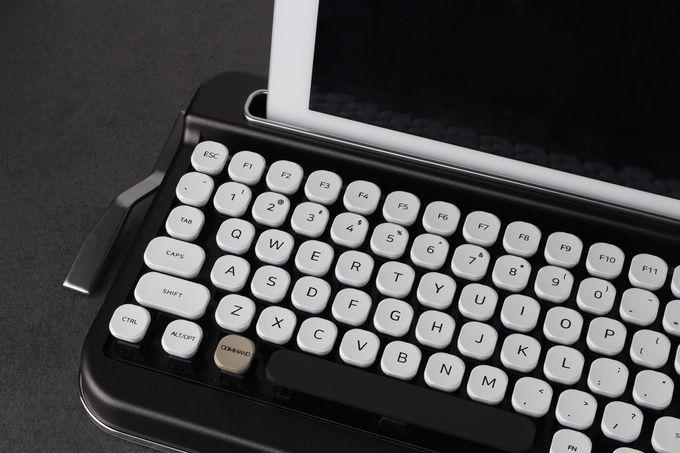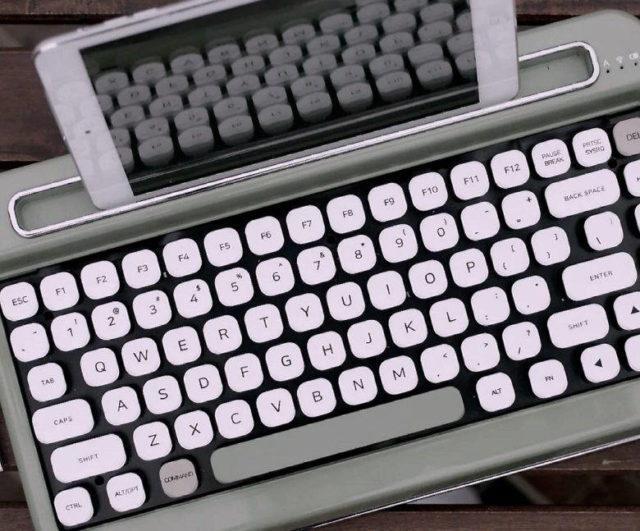The first image is the image on the left, the second image is the image on the right. Assess this claim about the two images: "One image includes a pair of human hands with one typewriter device.". Correct or not? Answer yes or no. No. The first image is the image on the left, the second image is the image on the right. For the images shown, is this caption "One photo includes a pair of human hands." true? Answer yes or no. No. 